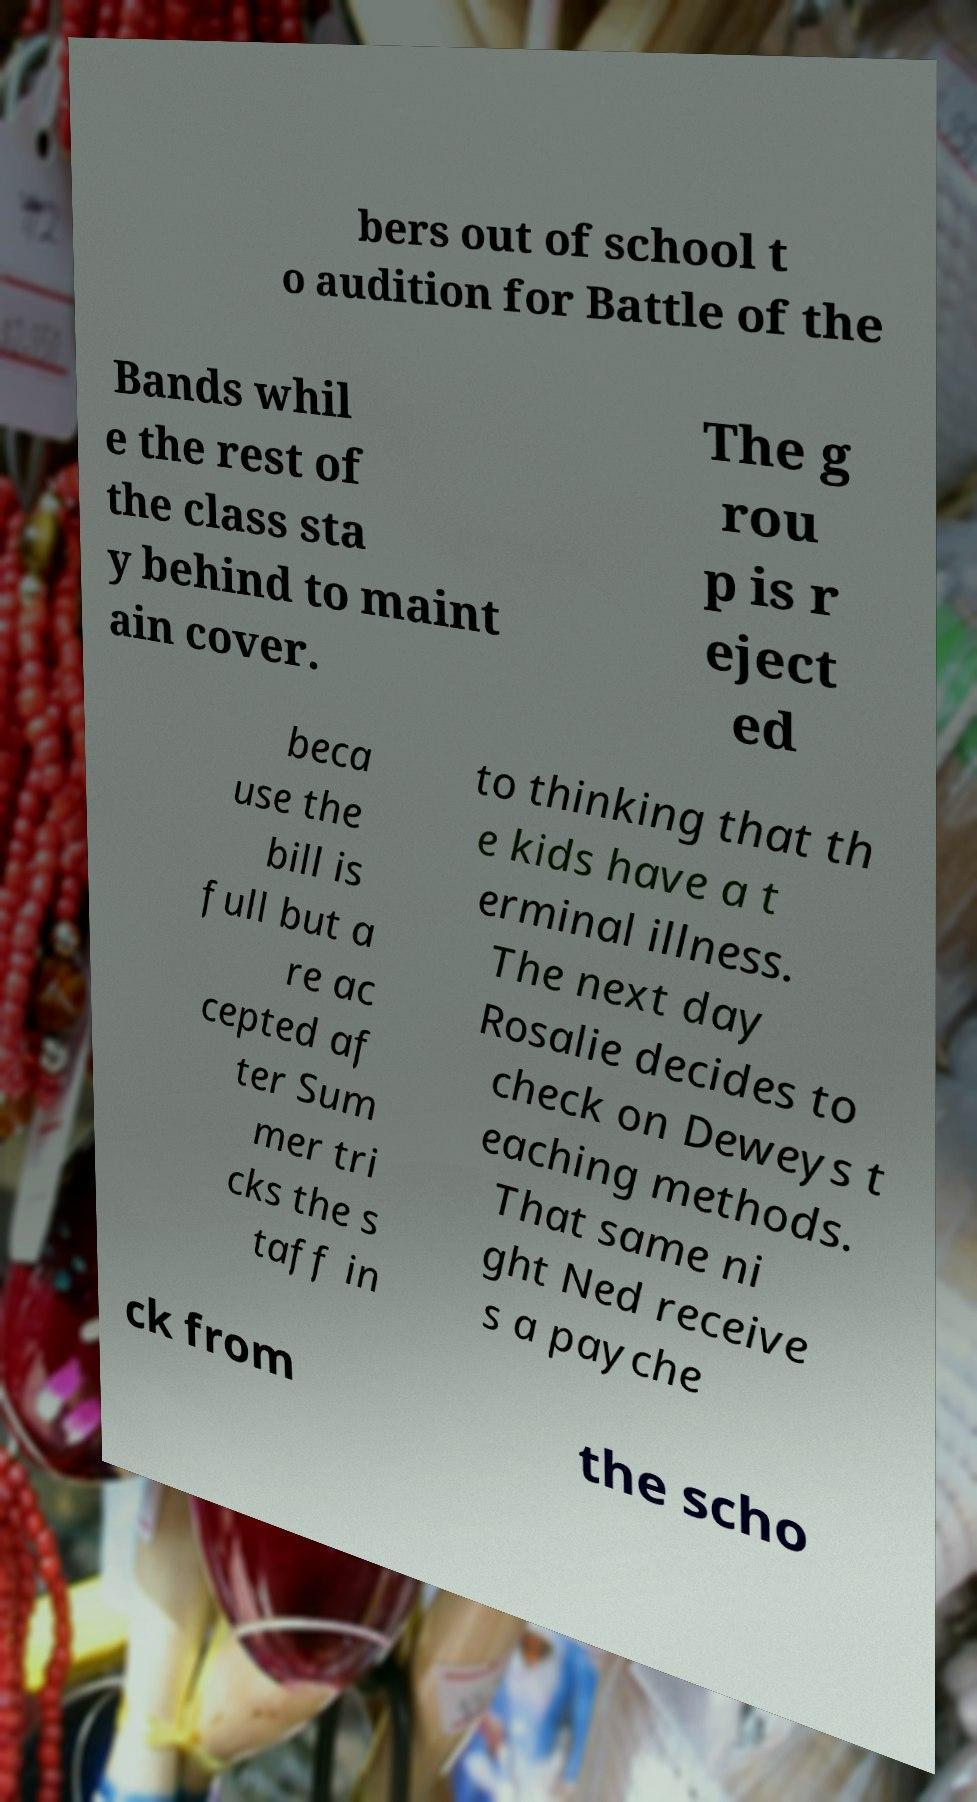Please read and relay the text visible in this image. What does it say? bers out of school t o audition for Battle of the Bands whil e the rest of the class sta y behind to maint ain cover. The g rou p is r eject ed beca use the bill is full but a re ac cepted af ter Sum mer tri cks the s taff in to thinking that th e kids have a t erminal illness. The next day Rosalie decides to check on Deweys t eaching methods. That same ni ght Ned receive s a payche ck from the scho 